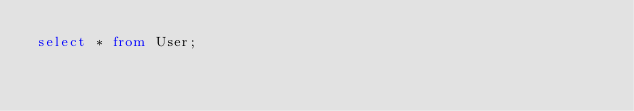<code> <loc_0><loc_0><loc_500><loc_500><_SQL_>select * from User;</code> 